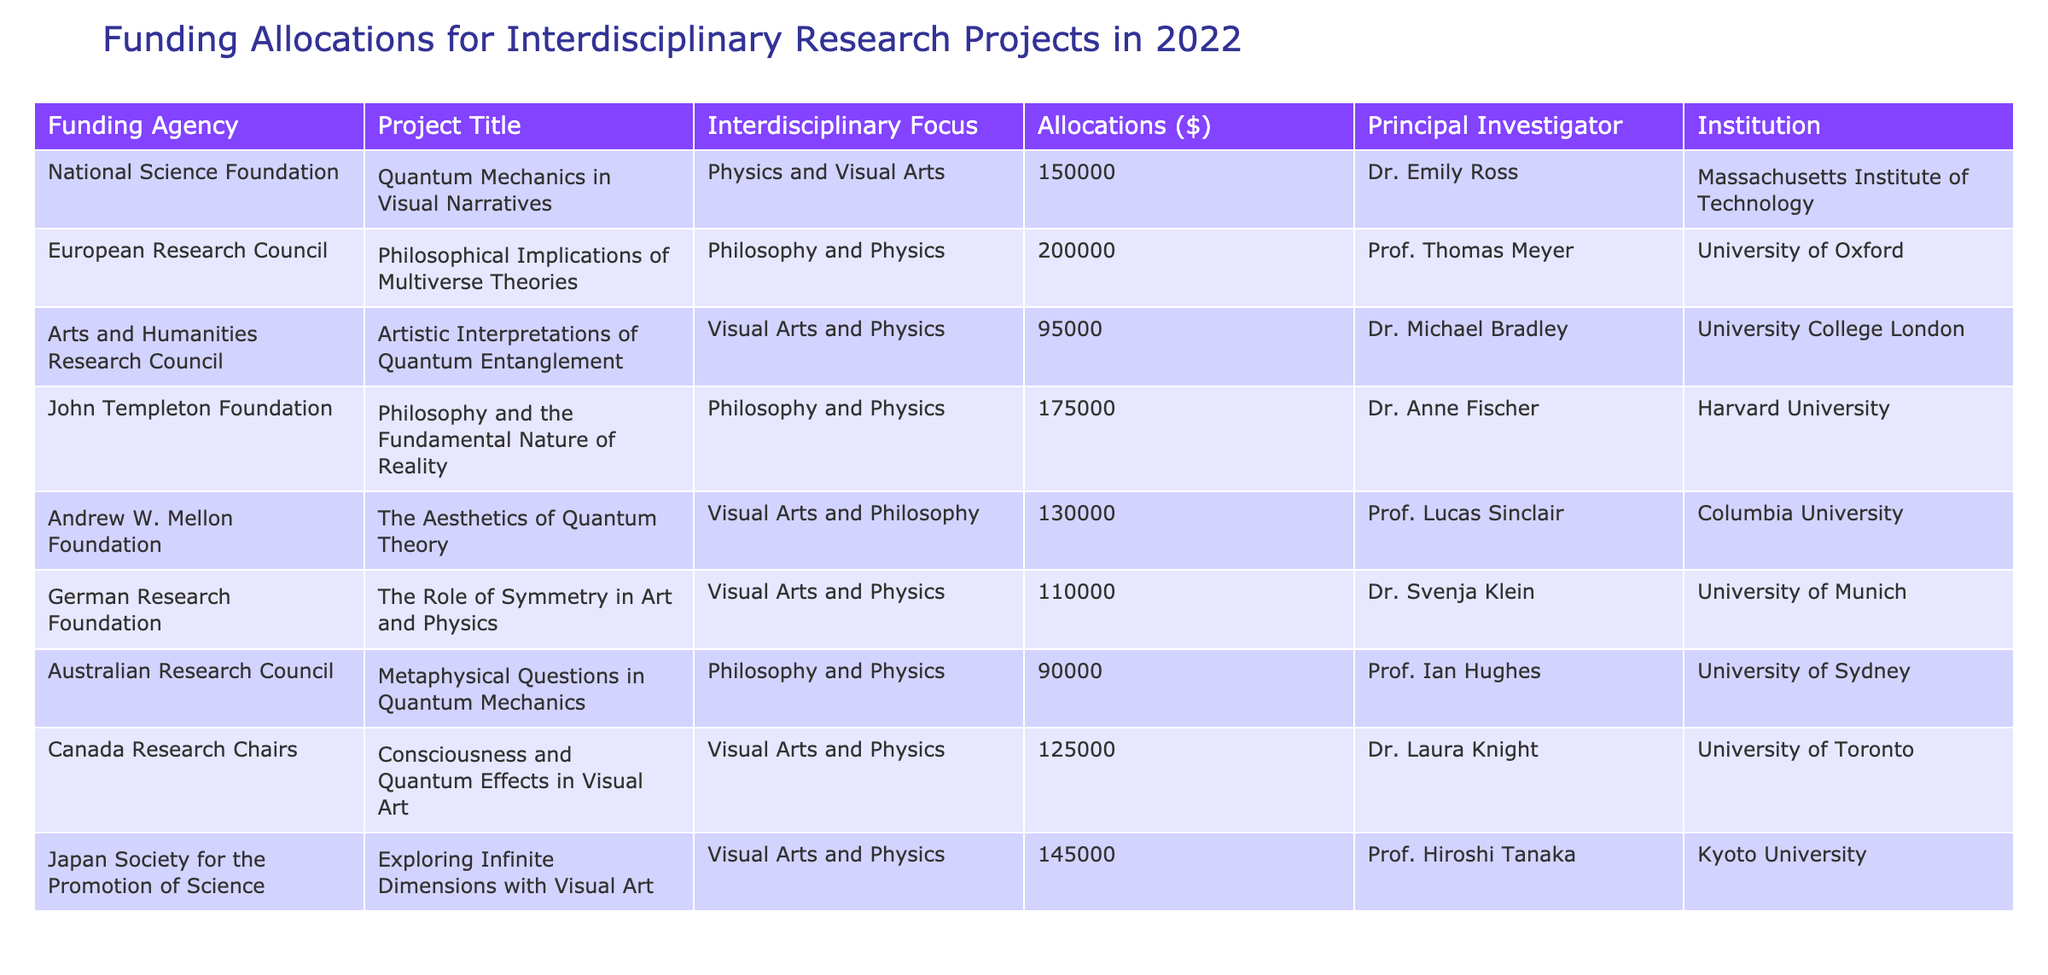What is the total funding allocated for projects focusing on Philosophy and Physics? To find the total funding for projects in this category, we look at all entries under the “Interdisciplinary Focus” column that match "Philosophy and Physics." The relevant projects are: "Philosophical Implications of Multiverse Theories" with $200,000, "Philosophy and the Fundamental Nature of Reality" with $175,000, and "Metaphysical Questions in Quantum Mechanics" with $90,000. Adding these together gives $200,000 + $175,000 + $90,000 = $465,000.
Answer: $465,000 Which project received the highest allocation? By examining the "Allocations ($)" column, we notice that the project "Philosophical Implications of Multiverse Theories" has the highest allocation of $200,000 among all listed projects.
Answer: $200,000 Did any project focus solely on Visual Arts and receive an allocation over $100,000? We need to check the "Interdisciplinary Focus" column for projects categorized under "Visual Arts" then see their allocations. The projects "The Aesthetics of Quantum Theory" with $130,000 and "Exploring Infinite Dimensions with Visual Art" with $145,000 fall under this focus and both exceed $100,000. Therefore, the answer is yes.
Answer: Yes What is the average funding allocated for all projects listed in the table? First, we sum the allocations of all projects: $150,000 + $200,000 + $95,000 + $175,000 + $130,000 + $110,000 + $90,000 + $125,000 + $145,000 = $1,215,000. Then, since there are 9 projects, we divide by 9 to calculate the average: $1,215,000 / 9 = $135,000.
Answer: $135,000 Is "Germany" represented in the table by any funding agency? Looking at the "Funding Agency" column, "German Research Foundation" is listed, which indicates that Germany is indeed represented in the table.
Answer: Yes What is the difference between the highest and lowest funding allocations in the table? To find this, first identify the highest allocation, which is $200,000 for the project "Philosophical Implications of Multiverse Theories," and the lowest allocation, which is $90,000 for "Artistic Interpretations of Quantum Entanglement." The difference is $200,000 - $90,000 = $110,000.
Answer: $110,000 